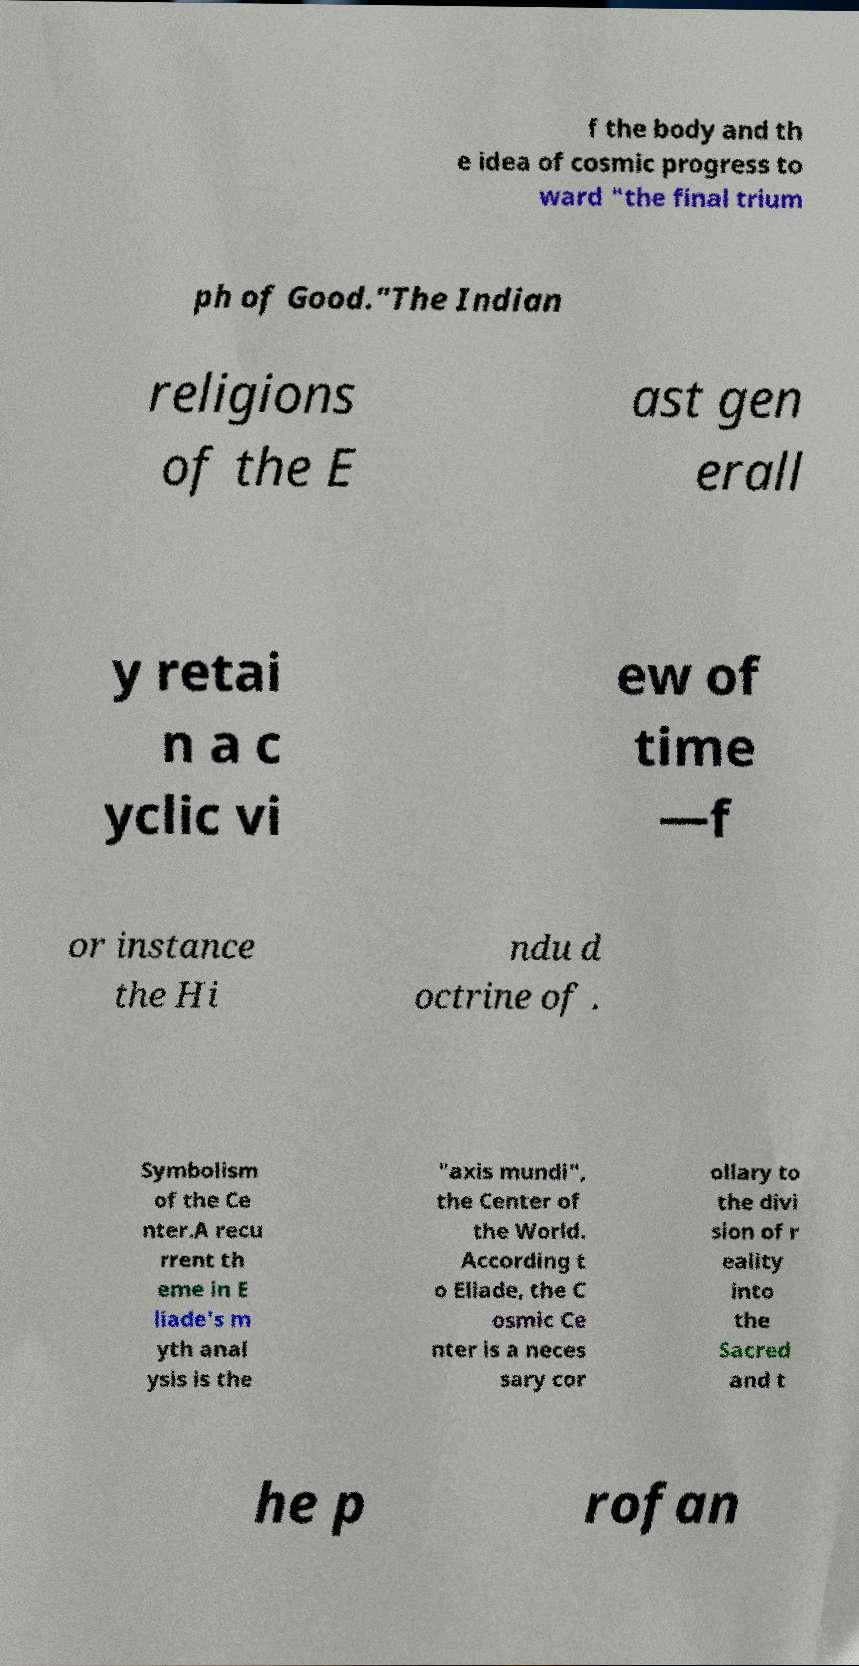What messages or text are displayed in this image? I need them in a readable, typed format. f the body and th e idea of cosmic progress to ward "the final trium ph of Good."The Indian religions of the E ast gen erall y retai n a c yclic vi ew of time —f or instance the Hi ndu d octrine of . Symbolism of the Ce nter.A recu rrent th eme in E liade's m yth anal ysis is the "axis mundi", the Center of the World. According t o Eliade, the C osmic Ce nter is a neces sary cor ollary to the divi sion of r eality into the Sacred and t he p rofan 